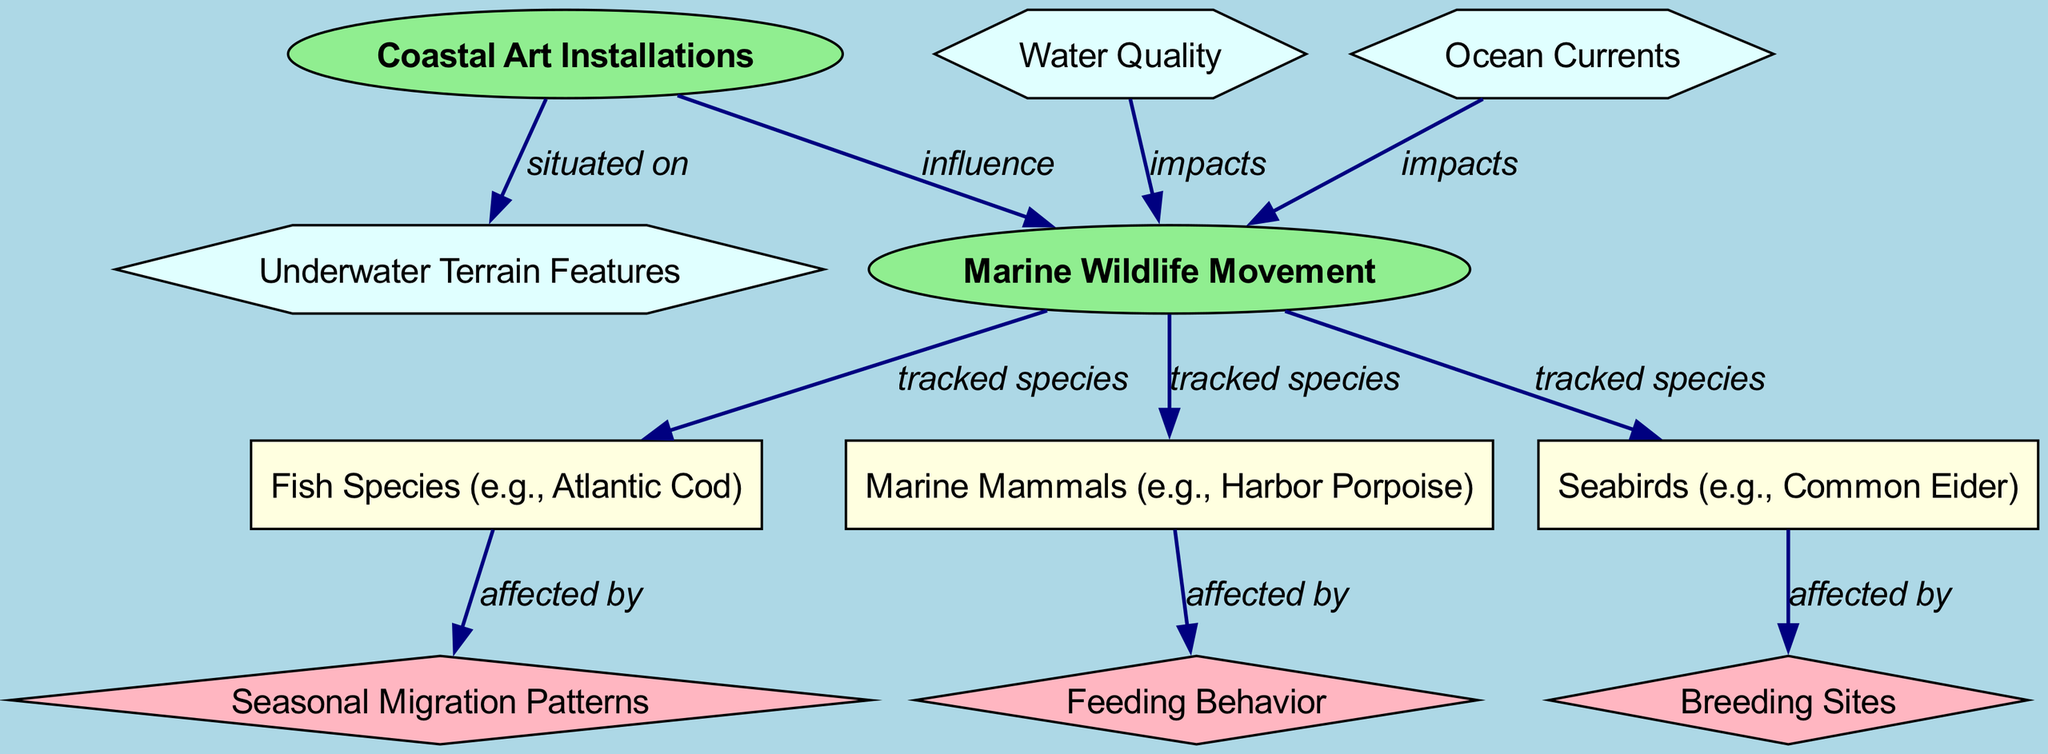What are the marine species tracked in this diagram? The diagram lists three marine species tracked: Fish Species (e.g., Atlantic Cod), Marine Mammals (e.g., Harbor Porpoise), and Seabirds (e.g., Common Eider).
Answer: Fish Species, Marine Mammals, Seabirds How many core nodes are present in the diagram? The diagram includes two core nodes: Coastal Art Installations and Marine Wildlife Movement.
Answer: 2 What type of behavior is affected by Fish Species? According to the diagram, Fish Species are affected by Seasonal Migration Patterns.
Answer: Seasonal Migration Patterns How does Water Quality impact Marine Wildlife Movement? The diagram shows an edge from Water Quality to Marine Wildlife Movement, indicating that it has an impact on it.
Answer: Impacts What relationship exists between Coastal Art Installations and Underwater Terrain Features? The diagram states that Coastal Art Installations are situated on Underwater Terrain Features, indicating a direct connection.
Answer: Situated on What specific behavior do Seabirds exhibit in relation to their Breeding Sites? The diagram indicates that Seabirds are affected by their Breeding Sites, highlighting a behavioral connection.
Answer: Affected by Which node influences Marine Wildlife Movement? The diagram shows an influence edge from Coastal Art Installations to Marine Wildlife Movement, indicating that the former affects the latter.
Answer: Coastal Art Installations Which type of environmental factors directly impact Marine Wildlife Movement? The diagram highlights that both Water Quality and Ocean Currents impact Marine Wildlife Movement, demonstrating these environmental effects.
Answer: Water Quality, Ocean Currents What are the types of nodes in this diagram? The diagram contains four types of nodes: core, species, behavior, and environmental, showcasing various aspects related to marine wildlife.
Answer: Core, species, behavior, environmental 